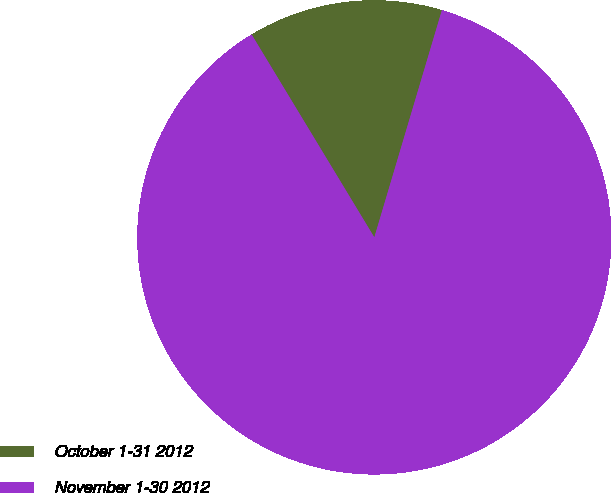<chart> <loc_0><loc_0><loc_500><loc_500><pie_chart><fcel>October 1-31 2012<fcel>November 1-30 2012<nl><fcel>13.26%<fcel>86.74%<nl></chart> 